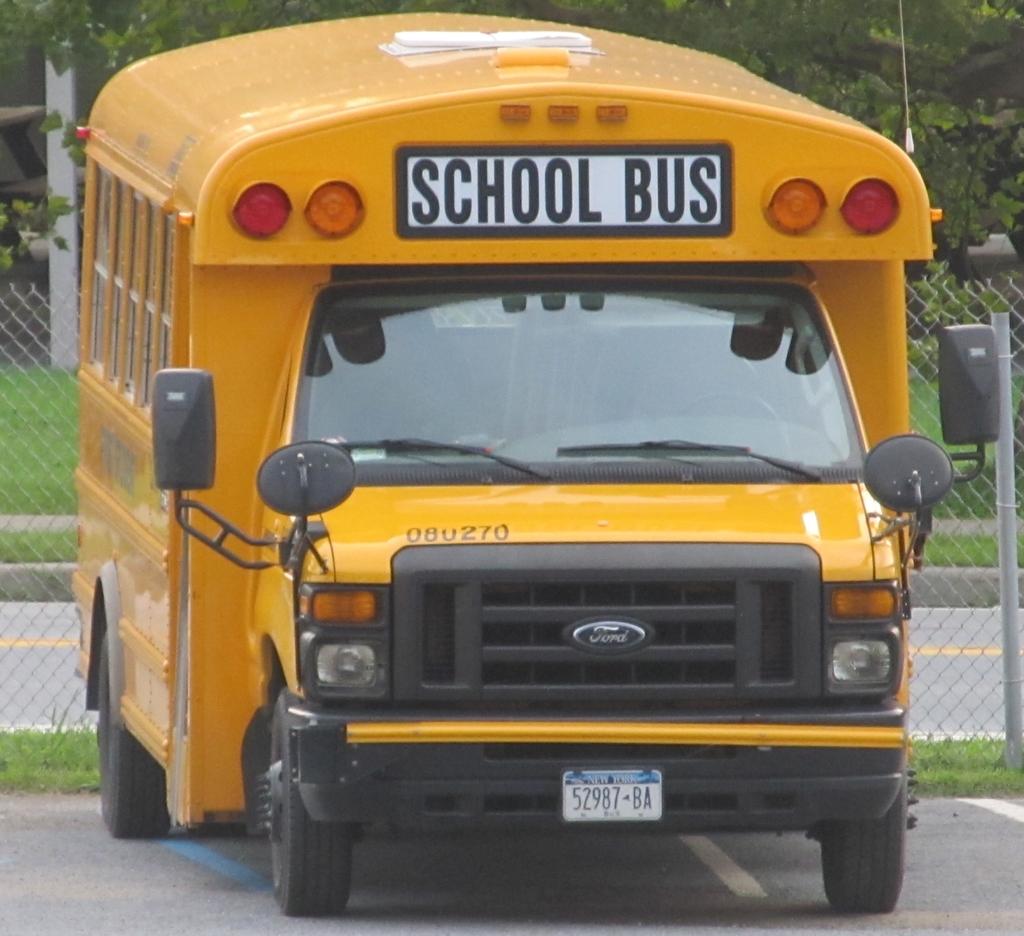What is the buses license plate number?
Ensure brevity in your answer.  52987-ba. Is this a ford bus?
Give a very brief answer. Yes. 